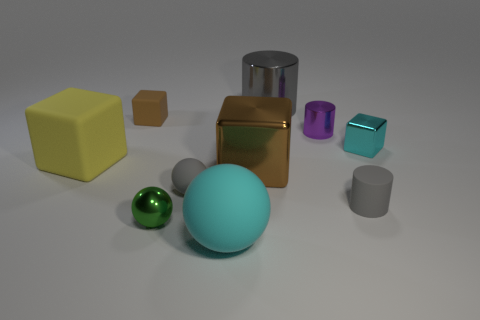Subtract all cylinders. How many objects are left? 7 Subtract all big gray metallic cylinders. Subtract all purple cylinders. How many objects are left? 8 Add 6 big brown things. How many big brown things are left? 7 Add 1 large brown objects. How many large brown objects exist? 2 Subtract 0 green cylinders. How many objects are left? 10 